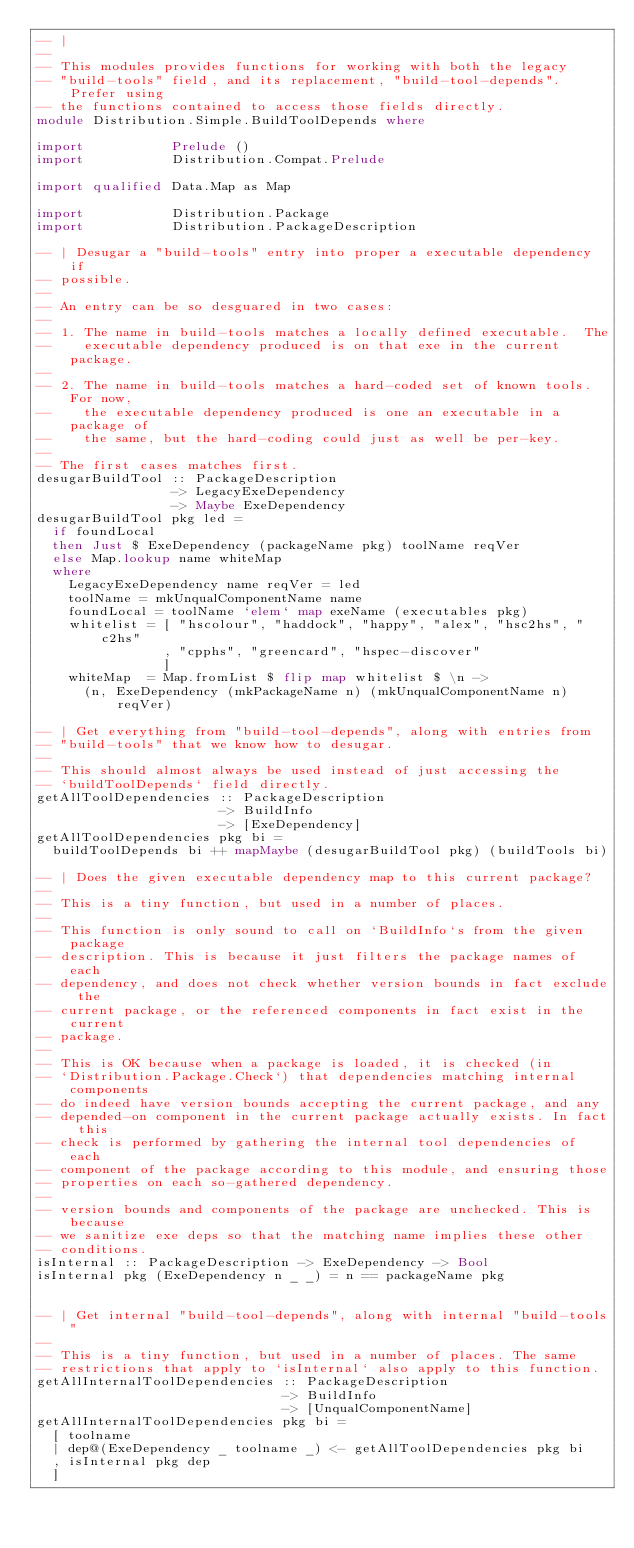Convert code to text. <code><loc_0><loc_0><loc_500><loc_500><_Haskell_>-- |
--
-- This modules provides functions for working with both the legacy
-- "build-tools" field, and its replacement, "build-tool-depends". Prefer using
-- the functions contained to access those fields directly.
module Distribution.Simple.BuildToolDepends where

import           Prelude ()
import           Distribution.Compat.Prelude

import qualified Data.Map as Map

import           Distribution.Package
import           Distribution.PackageDescription

-- | Desugar a "build-tools" entry into proper a executable dependency if
-- possible.
--
-- An entry can be so desguared in two cases:
--
-- 1. The name in build-tools matches a locally defined executable.  The
--    executable dependency produced is on that exe in the current package.
--
-- 2. The name in build-tools matches a hard-coded set of known tools.  For now,
--    the executable dependency produced is one an executable in a package of
--    the same, but the hard-coding could just as well be per-key.
--
-- The first cases matches first.
desugarBuildTool :: PackageDescription
                 -> LegacyExeDependency
                 -> Maybe ExeDependency
desugarBuildTool pkg led =
  if foundLocal
  then Just $ ExeDependency (packageName pkg) toolName reqVer
  else Map.lookup name whiteMap
  where
    LegacyExeDependency name reqVer = led
    toolName = mkUnqualComponentName name
    foundLocal = toolName `elem` map exeName (executables pkg)
    whitelist = [ "hscolour", "haddock", "happy", "alex", "hsc2hs", "c2hs"
                , "cpphs", "greencard", "hspec-discover"
                ]
    whiteMap  = Map.fromList $ flip map whitelist $ \n ->
      (n, ExeDependency (mkPackageName n) (mkUnqualComponentName n) reqVer)

-- | Get everything from "build-tool-depends", along with entries from
-- "build-tools" that we know how to desugar.
--
-- This should almost always be used instead of just accessing the
-- `buildToolDepends` field directly.
getAllToolDependencies :: PackageDescription
                       -> BuildInfo
                       -> [ExeDependency]
getAllToolDependencies pkg bi =
  buildToolDepends bi ++ mapMaybe (desugarBuildTool pkg) (buildTools bi)

-- | Does the given executable dependency map to this current package?
--
-- This is a tiny function, but used in a number of places.
--
-- This function is only sound to call on `BuildInfo`s from the given package
-- description. This is because it just filters the package names of each
-- dependency, and does not check whether version bounds in fact exclude the
-- current package, or the referenced components in fact exist in the current
-- package.
--
-- This is OK because when a package is loaded, it is checked (in
-- `Distribution.Package.Check`) that dependencies matching internal components
-- do indeed have version bounds accepting the current package, and any
-- depended-on component in the current package actually exists. In fact this
-- check is performed by gathering the internal tool dependencies of each
-- component of the package according to this module, and ensuring those
-- properties on each so-gathered dependency.
--
-- version bounds and components of the package are unchecked. This is because
-- we sanitize exe deps so that the matching name implies these other
-- conditions.
isInternal :: PackageDescription -> ExeDependency -> Bool
isInternal pkg (ExeDependency n _ _) = n == packageName pkg


-- | Get internal "build-tool-depends", along with internal "build-tools"
--
-- This is a tiny function, but used in a number of places. The same
-- restrictions that apply to `isInternal` also apply to this function.
getAllInternalToolDependencies :: PackageDescription
                               -> BuildInfo
                               -> [UnqualComponentName]
getAllInternalToolDependencies pkg bi =
  [ toolname
  | dep@(ExeDependency _ toolname _) <- getAllToolDependencies pkg bi
  , isInternal pkg dep
  ]
</code> 